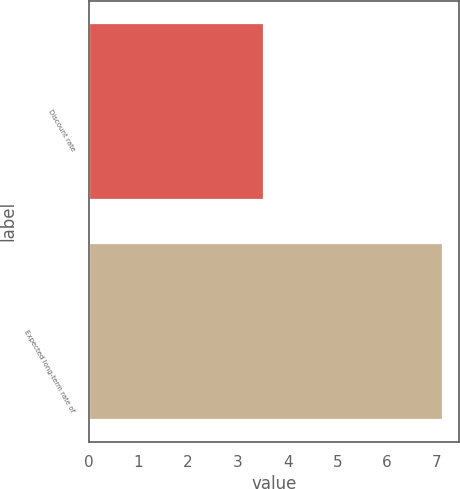<chart> <loc_0><loc_0><loc_500><loc_500><bar_chart><fcel>Discount rate<fcel>Expected long-term rate of<nl><fcel>3.5<fcel>7.1<nl></chart> 